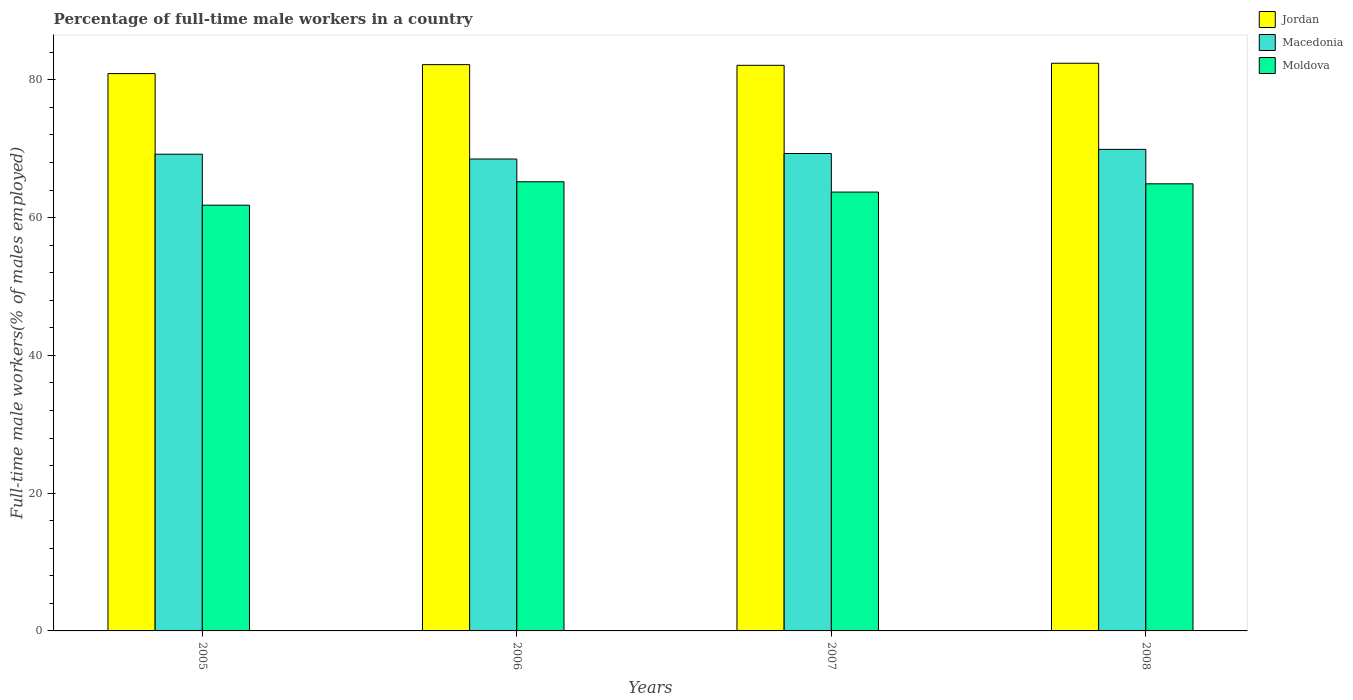How many different coloured bars are there?
Make the answer very short. 3. How many bars are there on the 4th tick from the left?
Provide a succinct answer. 3. What is the label of the 3rd group of bars from the left?
Make the answer very short. 2007. In how many cases, is the number of bars for a given year not equal to the number of legend labels?
Keep it short and to the point. 0. What is the percentage of full-time male workers in Macedonia in 2006?
Make the answer very short. 68.5. Across all years, what is the maximum percentage of full-time male workers in Moldova?
Ensure brevity in your answer.  65.2. Across all years, what is the minimum percentage of full-time male workers in Jordan?
Your answer should be compact. 80.9. In which year was the percentage of full-time male workers in Moldova maximum?
Your response must be concise. 2006. In which year was the percentage of full-time male workers in Moldova minimum?
Provide a succinct answer. 2005. What is the total percentage of full-time male workers in Macedonia in the graph?
Make the answer very short. 276.9. What is the difference between the percentage of full-time male workers in Macedonia in 2005 and that in 2006?
Your response must be concise. 0.7. What is the difference between the percentage of full-time male workers in Macedonia in 2005 and the percentage of full-time male workers in Jordan in 2006?
Provide a succinct answer. -13. What is the average percentage of full-time male workers in Macedonia per year?
Your response must be concise. 69.23. What is the ratio of the percentage of full-time male workers in Jordan in 2006 to that in 2008?
Give a very brief answer. 1. What is the difference between the highest and the second highest percentage of full-time male workers in Moldova?
Keep it short and to the point. 0.3. What is the difference between the highest and the lowest percentage of full-time male workers in Macedonia?
Your answer should be very brief. 1.4. In how many years, is the percentage of full-time male workers in Moldova greater than the average percentage of full-time male workers in Moldova taken over all years?
Offer a terse response. 2. Is the sum of the percentage of full-time male workers in Jordan in 2007 and 2008 greater than the maximum percentage of full-time male workers in Macedonia across all years?
Ensure brevity in your answer.  Yes. What does the 1st bar from the left in 2008 represents?
Your response must be concise. Jordan. What does the 3rd bar from the right in 2008 represents?
Make the answer very short. Jordan. Is it the case that in every year, the sum of the percentage of full-time male workers in Macedonia and percentage of full-time male workers in Moldova is greater than the percentage of full-time male workers in Jordan?
Ensure brevity in your answer.  Yes. Are all the bars in the graph horizontal?
Keep it short and to the point. No. What is the difference between two consecutive major ticks on the Y-axis?
Make the answer very short. 20. Does the graph contain grids?
Offer a terse response. No. How many legend labels are there?
Keep it short and to the point. 3. What is the title of the graph?
Your answer should be very brief. Percentage of full-time male workers in a country. Does "Mongolia" appear as one of the legend labels in the graph?
Give a very brief answer. No. What is the label or title of the X-axis?
Offer a terse response. Years. What is the label or title of the Y-axis?
Give a very brief answer. Full-time male workers(% of males employed). What is the Full-time male workers(% of males employed) in Jordan in 2005?
Offer a terse response. 80.9. What is the Full-time male workers(% of males employed) of Macedonia in 2005?
Your response must be concise. 69.2. What is the Full-time male workers(% of males employed) of Moldova in 2005?
Offer a very short reply. 61.8. What is the Full-time male workers(% of males employed) of Jordan in 2006?
Your answer should be very brief. 82.2. What is the Full-time male workers(% of males employed) in Macedonia in 2006?
Keep it short and to the point. 68.5. What is the Full-time male workers(% of males employed) in Moldova in 2006?
Your response must be concise. 65.2. What is the Full-time male workers(% of males employed) in Jordan in 2007?
Give a very brief answer. 82.1. What is the Full-time male workers(% of males employed) in Macedonia in 2007?
Keep it short and to the point. 69.3. What is the Full-time male workers(% of males employed) of Moldova in 2007?
Ensure brevity in your answer.  63.7. What is the Full-time male workers(% of males employed) of Jordan in 2008?
Your response must be concise. 82.4. What is the Full-time male workers(% of males employed) of Macedonia in 2008?
Your answer should be very brief. 69.9. What is the Full-time male workers(% of males employed) of Moldova in 2008?
Make the answer very short. 64.9. Across all years, what is the maximum Full-time male workers(% of males employed) of Jordan?
Provide a short and direct response. 82.4. Across all years, what is the maximum Full-time male workers(% of males employed) of Macedonia?
Ensure brevity in your answer.  69.9. Across all years, what is the maximum Full-time male workers(% of males employed) in Moldova?
Your answer should be compact. 65.2. Across all years, what is the minimum Full-time male workers(% of males employed) in Jordan?
Offer a terse response. 80.9. Across all years, what is the minimum Full-time male workers(% of males employed) in Macedonia?
Keep it short and to the point. 68.5. Across all years, what is the minimum Full-time male workers(% of males employed) of Moldova?
Offer a very short reply. 61.8. What is the total Full-time male workers(% of males employed) in Jordan in the graph?
Your answer should be compact. 327.6. What is the total Full-time male workers(% of males employed) of Macedonia in the graph?
Your answer should be very brief. 276.9. What is the total Full-time male workers(% of males employed) in Moldova in the graph?
Keep it short and to the point. 255.6. What is the difference between the Full-time male workers(% of males employed) in Moldova in 2005 and that in 2006?
Your answer should be compact. -3.4. What is the difference between the Full-time male workers(% of males employed) of Jordan in 2005 and that in 2007?
Ensure brevity in your answer.  -1.2. What is the difference between the Full-time male workers(% of males employed) in Moldova in 2005 and that in 2007?
Your answer should be very brief. -1.9. What is the difference between the Full-time male workers(% of males employed) of Macedonia in 2005 and that in 2008?
Make the answer very short. -0.7. What is the difference between the Full-time male workers(% of males employed) in Moldova in 2005 and that in 2008?
Make the answer very short. -3.1. What is the difference between the Full-time male workers(% of males employed) in Macedonia in 2006 and that in 2008?
Your answer should be very brief. -1.4. What is the difference between the Full-time male workers(% of males employed) of Jordan in 2007 and that in 2008?
Make the answer very short. -0.3. What is the difference between the Full-time male workers(% of males employed) in Moldova in 2007 and that in 2008?
Give a very brief answer. -1.2. What is the difference between the Full-time male workers(% of males employed) in Jordan in 2005 and the Full-time male workers(% of males employed) in Macedonia in 2006?
Your answer should be compact. 12.4. What is the difference between the Full-time male workers(% of males employed) in Jordan in 2005 and the Full-time male workers(% of males employed) in Moldova in 2006?
Give a very brief answer. 15.7. What is the difference between the Full-time male workers(% of males employed) in Macedonia in 2005 and the Full-time male workers(% of males employed) in Moldova in 2006?
Make the answer very short. 4. What is the difference between the Full-time male workers(% of males employed) in Jordan in 2005 and the Full-time male workers(% of males employed) in Macedonia in 2007?
Your response must be concise. 11.6. What is the difference between the Full-time male workers(% of males employed) of Jordan in 2005 and the Full-time male workers(% of males employed) of Moldova in 2007?
Offer a very short reply. 17.2. What is the difference between the Full-time male workers(% of males employed) of Macedonia in 2005 and the Full-time male workers(% of males employed) of Moldova in 2007?
Your answer should be compact. 5.5. What is the difference between the Full-time male workers(% of males employed) of Jordan in 2005 and the Full-time male workers(% of males employed) of Moldova in 2008?
Your answer should be very brief. 16. What is the difference between the Full-time male workers(% of males employed) of Macedonia in 2006 and the Full-time male workers(% of males employed) of Moldova in 2007?
Ensure brevity in your answer.  4.8. What is the difference between the Full-time male workers(% of males employed) of Jordan in 2006 and the Full-time male workers(% of males employed) of Macedonia in 2008?
Offer a terse response. 12.3. What is the difference between the Full-time male workers(% of males employed) in Macedonia in 2006 and the Full-time male workers(% of males employed) in Moldova in 2008?
Your answer should be very brief. 3.6. What is the average Full-time male workers(% of males employed) in Jordan per year?
Make the answer very short. 81.9. What is the average Full-time male workers(% of males employed) of Macedonia per year?
Your response must be concise. 69.22. What is the average Full-time male workers(% of males employed) of Moldova per year?
Your answer should be compact. 63.9. In the year 2005, what is the difference between the Full-time male workers(% of males employed) of Jordan and Full-time male workers(% of males employed) of Macedonia?
Give a very brief answer. 11.7. In the year 2005, what is the difference between the Full-time male workers(% of males employed) in Macedonia and Full-time male workers(% of males employed) in Moldova?
Ensure brevity in your answer.  7.4. In the year 2006, what is the difference between the Full-time male workers(% of males employed) in Jordan and Full-time male workers(% of males employed) in Moldova?
Keep it short and to the point. 17. In the year 2006, what is the difference between the Full-time male workers(% of males employed) in Macedonia and Full-time male workers(% of males employed) in Moldova?
Offer a very short reply. 3.3. In the year 2007, what is the difference between the Full-time male workers(% of males employed) in Jordan and Full-time male workers(% of males employed) in Moldova?
Give a very brief answer. 18.4. In the year 2007, what is the difference between the Full-time male workers(% of males employed) of Macedonia and Full-time male workers(% of males employed) of Moldova?
Your answer should be very brief. 5.6. In the year 2008, what is the difference between the Full-time male workers(% of males employed) of Jordan and Full-time male workers(% of males employed) of Moldova?
Ensure brevity in your answer.  17.5. In the year 2008, what is the difference between the Full-time male workers(% of males employed) of Macedonia and Full-time male workers(% of males employed) of Moldova?
Your answer should be compact. 5. What is the ratio of the Full-time male workers(% of males employed) of Jordan in 2005 to that in 2006?
Ensure brevity in your answer.  0.98. What is the ratio of the Full-time male workers(% of males employed) in Macedonia in 2005 to that in 2006?
Offer a very short reply. 1.01. What is the ratio of the Full-time male workers(% of males employed) of Moldova in 2005 to that in 2006?
Make the answer very short. 0.95. What is the ratio of the Full-time male workers(% of males employed) of Jordan in 2005 to that in 2007?
Give a very brief answer. 0.99. What is the ratio of the Full-time male workers(% of males employed) in Moldova in 2005 to that in 2007?
Offer a very short reply. 0.97. What is the ratio of the Full-time male workers(% of males employed) of Jordan in 2005 to that in 2008?
Offer a very short reply. 0.98. What is the ratio of the Full-time male workers(% of males employed) in Moldova in 2005 to that in 2008?
Your response must be concise. 0.95. What is the ratio of the Full-time male workers(% of males employed) of Jordan in 2006 to that in 2007?
Make the answer very short. 1. What is the ratio of the Full-time male workers(% of males employed) in Macedonia in 2006 to that in 2007?
Ensure brevity in your answer.  0.99. What is the ratio of the Full-time male workers(% of males employed) in Moldova in 2006 to that in 2007?
Ensure brevity in your answer.  1.02. What is the ratio of the Full-time male workers(% of males employed) of Moldova in 2006 to that in 2008?
Provide a succinct answer. 1. What is the ratio of the Full-time male workers(% of males employed) in Jordan in 2007 to that in 2008?
Make the answer very short. 1. What is the ratio of the Full-time male workers(% of males employed) in Macedonia in 2007 to that in 2008?
Provide a succinct answer. 0.99. What is the ratio of the Full-time male workers(% of males employed) in Moldova in 2007 to that in 2008?
Your answer should be compact. 0.98. What is the difference between the highest and the second highest Full-time male workers(% of males employed) of Jordan?
Make the answer very short. 0.2. What is the difference between the highest and the second highest Full-time male workers(% of males employed) of Moldova?
Make the answer very short. 0.3. What is the difference between the highest and the lowest Full-time male workers(% of males employed) of Macedonia?
Provide a succinct answer. 1.4. 